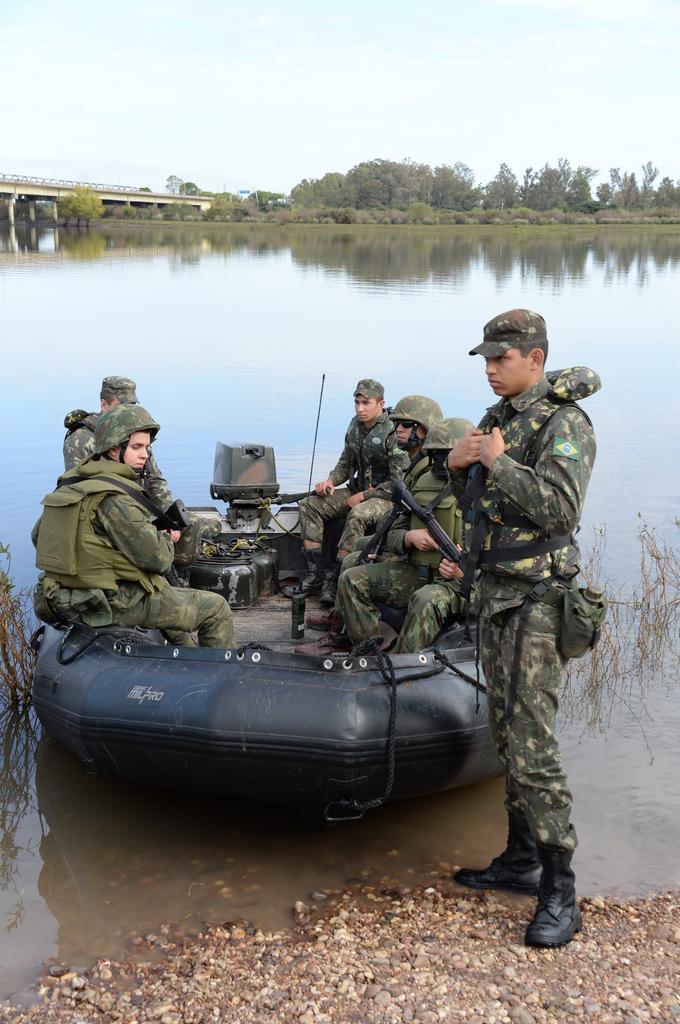How would you summarize this image in a sentence or two? In the picture we can see this person wearing uniform, cap and shoes is standing on the rocks and these people wearing uniforms, caps and backpacks are sitting in the inflatable boat which is floating on the water. In the background, we can see the bridge, trees and the sky. 